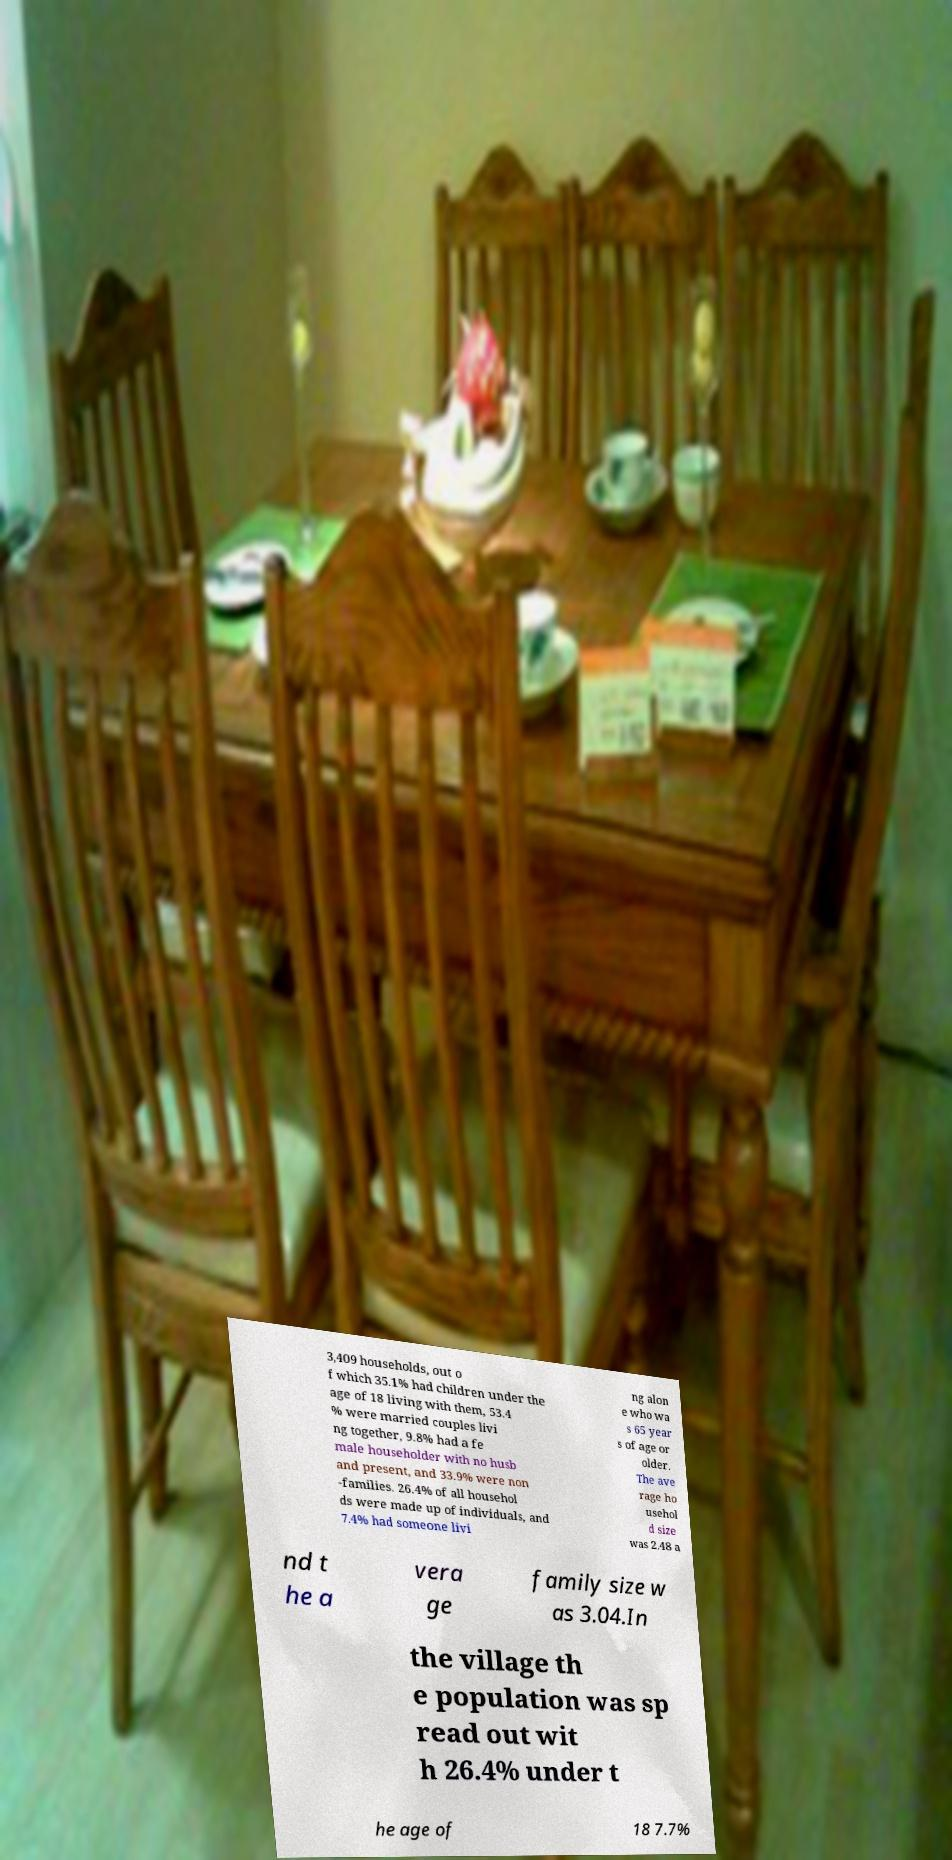What messages or text are displayed in this image? I need them in a readable, typed format. 3,409 households, out o f which 35.1% had children under the age of 18 living with them, 53.4 % were married couples livi ng together, 9.8% had a fe male householder with no husb and present, and 33.9% were non -families. 26.4% of all househol ds were made up of individuals, and 7.4% had someone livi ng alon e who wa s 65 year s of age or older. The ave rage ho usehol d size was 2.48 a nd t he a vera ge family size w as 3.04.In the village th e population was sp read out wit h 26.4% under t he age of 18 7.7% 